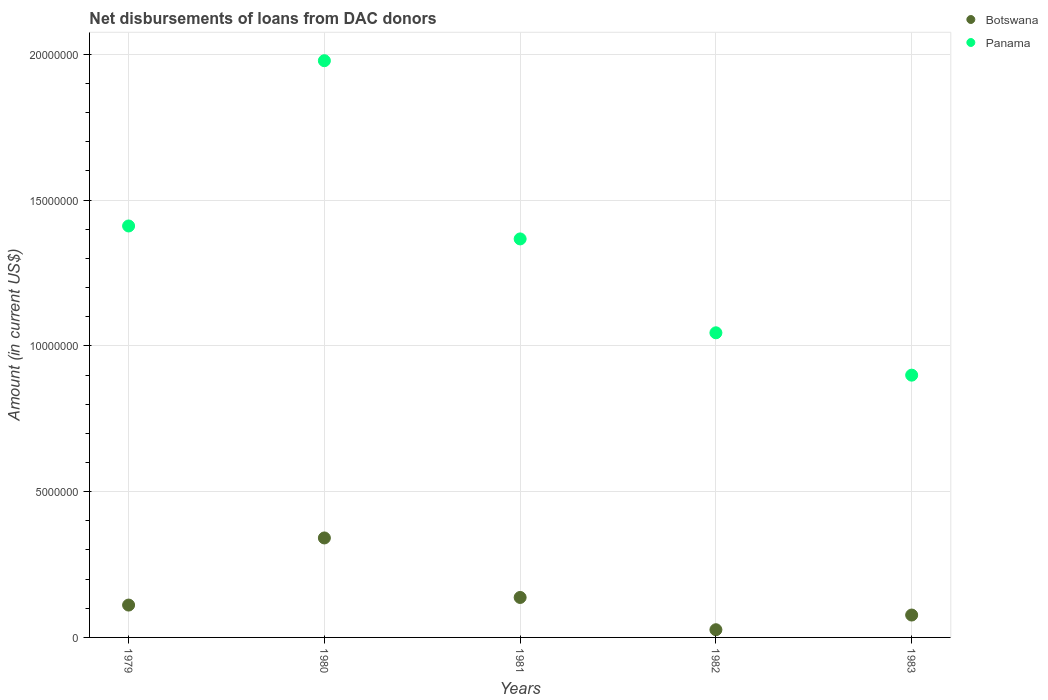What is the amount of loans disbursed in Panama in 1981?
Offer a terse response. 1.37e+07. Across all years, what is the maximum amount of loans disbursed in Botswana?
Make the answer very short. 3.41e+06. Across all years, what is the minimum amount of loans disbursed in Panama?
Make the answer very short. 9.00e+06. In which year was the amount of loans disbursed in Panama minimum?
Provide a short and direct response. 1983. What is the total amount of loans disbursed in Botswana in the graph?
Offer a very short reply. 6.92e+06. What is the difference between the amount of loans disbursed in Panama in 1980 and that in 1983?
Your answer should be compact. 1.08e+07. What is the difference between the amount of loans disbursed in Botswana in 1979 and the amount of loans disbursed in Panama in 1983?
Give a very brief answer. -7.89e+06. What is the average amount of loans disbursed in Panama per year?
Offer a very short reply. 1.34e+07. In the year 1983, what is the difference between the amount of loans disbursed in Botswana and amount of loans disbursed in Panama?
Offer a very short reply. -8.23e+06. What is the ratio of the amount of loans disbursed in Panama in 1979 to that in 1980?
Offer a terse response. 0.71. What is the difference between the highest and the second highest amount of loans disbursed in Botswana?
Keep it short and to the point. 2.04e+06. What is the difference between the highest and the lowest amount of loans disbursed in Panama?
Your answer should be compact. 1.08e+07. In how many years, is the amount of loans disbursed in Panama greater than the average amount of loans disbursed in Panama taken over all years?
Give a very brief answer. 3. Does the amount of loans disbursed in Panama monotonically increase over the years?
Keep it short and to the point. No. Is the amount of loans disbursed in Botswana strictly less than the amount of loans disbursed in Panama over the years?
Ensure brevity in your answer.  Yes. Does the graph contain any zero values?
Ensure brevity in your answer.  No. Where does the legend appear in the graph?
Keep it short and to the point. Top right. How are the legend labels stacked?
Keep it short and to the point. Vertical. What is the title of the graph?
Keep it short and to the point. Net disbursements of loans from DAC donors. What is the label or title of the Y-axis?
Offer a terse response. Amount (in current US$). What is the Amount (in current US$) in Botswana in 1979?
Ensure brevity in your answer.  1.11e+06. What is the Amount (in current US$) of Panama in 1979?
Ensure brevity in your answer.  1.41e+07. What is the Amount (in current US$) in Botswana in 1980?
Your response must be concise. 3.41e+06. What is the Amount (in current US$) in Panama in 1980?
Your answer should be very brief. 1.98e+07. What is the Amount (in current US$) in Botswana in 1981?
Give a very brief answer. 1.37e+06. What is the Amount (in current US$) of Panama in 1981?
Keep it short and to the point. 1.37e+07. What is the Amount (in current US$) in Botswana in 1982?
Provide a short and direct response. 2.64e+05. What is the Amount (in current US$) of Panama in 1982?
Offer a terse response. 1.04e+07. What is the Amount (in current US$) of Botswana in 1983?
Make the answer very short. 7.68e+05. What is the Amount (in current US$) in Panama in 1983?
Make the answer very short. 9.00e+06. Across all years, what is the maximum Amount (in current US$) of Botswana?
Offer a very short reply. 3.41e+06. Across all years, what is the maximum Amount (in current US$) of Panama?
Offer a terse response. 1.98e+07. Across all years, what is the minimum Amount (in current US$) in Botswana?
Make the answer very short. 2.64e+05. Across all years, what is the minimum Amount (in current US$) of Panama?
Keep it short and to the point. 9.00e+06. What is the total Amount (in current US$) in Botswana in the graph?
Your answer should be compact. 6.92e+06. What is the total Amount (in current US$) of Panama in the graph?
Provide a succinct answer. 6.70e+07. What is the difference between the Amount (in current US$) in Botswana in 1979 and that in 1980?
Offer a terse response. -2.30e+06. What is the difference between the Amount (in current US$) in Panama in 1979 and that in 1980?
Your answer should be compact. -5.67e+06. What is the difference between the Amount (in current US$) of Botswana in 1979 and that in 1981?
Ensure brevity in your answer.  -2.61e+05. What is the difference between the Amount (in current US$) in Panama in 1979 and that in 1981?
Offer a very short reply. 4.44e+05. What is the difference between the Amount (in current US$) in Botswana in 1979 and that in 1982?
Your answer should be compact. 8.46e+05. What is the difference between the Amount (in current US$) of Panama in 1979 and that in 1982?
Your answer should be compact. 3.66e+06. What is the difference between the Amount (in current US$) in Botswana in 1979 and that in 1983?
Keep it short and to the point. 3.42e+05. What is the difference between the Amount (in current US$) of Panama in 1979 and that in 1983?
Your response must be concise. 5.12e+06. What is the difference between the Amount (in current US$) of Botswana in 1980 and that in 1981?
Ensure brevity in your answer.  2.04e+06. What is the difference between the Amount (in current US$) of Panama in 1980 and that in 1981?
Your answer should be very brief. 6.11e+06. What is the difference between the Amount (in current US$) of Botswana in 1980 and that in 1982?
Your response must be concise. 3.15e+06. What is the difference between the Amount (in current US$) of Panama in 1980 and that in 1982?
Offer a terse response. 9.33e+06. What is the difference between the Amount (in current US$) in Botswana in 1980 and that in 1983?
Give a very brief answer. 2.64e+06. What is the difference between the Amount (in current US$) of Panama in 1980 and that in 1983?
Make the answer very short. 1.08e+07. What is the difference between the Amount (in current US$) in Botswana in 1981 and that in 1982?
Give a very brief answer. 1.11e+06. What is the difference between the Amount (in current US$) of Panama in 1981 and that in 1982?
Provide a short and direct response. 3.22e+06. What is the difference between the Amount (in current US$) of Botswana in 1981 and that in 1983?
Offer a very short reply. 6.03e+05. What is the difference between the Amount (in current US$) in Panama in 1981 and that in 1983?
Ensure brevity in your answer.  4.67e+06. What is the difference between the Amount (in current US$) in Botswana in 1982 and that in 1983?
Offer a terse response. -5.04e+05. What is the difference between the Amount (in current US$) in Panama in 1982 and that in 1983?
Your answer should be compact. 1.45e+06. What is the difference between the Amount (in current US$) in Botswana in 1979 and the Amount (in current US$) in Panama in 1980?
Ensure brevity in your answer.  -1.87e+07. What is the difference between the Amount (in current US$) of Botswana in 1979 and the Amount (in current US$) of Panama in 1981?
Provide a short and direct response. -1.26e+07. What is the difference between the Amount (in current US$) of Botswana in 1979 and the Amount (in current US$) of Panama in 1982?
Keep it short and to the point. -9.34e+06. What is the difference between the Amount (in current US$) in Botswana in 1979 and the Amount (in current US$) in Panama in 1983?
Provide a short and direct response. -7.89e+06. What is the difference between the Amount (in current US$) in Botswana in 1980 and the Amount (in current US$) in Panama in 1981?
Your answer should be compact. -1.03e+07. What is the difference between the Amount (in current US$) in Botswana in 1980 and the Amount (in current US$) in Panama in 1982?
Keep it short and to the point. -7.04e+06. What is the difference between the Amount (in current US$) of Botswana in 1980 and the Amount (in current US$) of Panama in 1983?
Your response must be concise. -5.58e+06. What is the difference between the Amount (in current US$) of Botswana in 1981 and the Amount (in current US$) of Panama in 1982?
Provide a succinct answer. -9.08e+06. What is the difference between the Amount (in current US$) in Botswana in 1981 and the Amount (in current US$) in Panama in 1983?
Make the answer very short. -7.62e+06. What is the difference between the Amount (in current US$) in Botswana in 1982 and the Amount (in current US$) in Panama in 1983?
Provide a succinct answer. -8.73e+06. What is the average Amount (in current US$) in Botswana per year?
Your answer should be very brief. 1.38e+06. What is the average Amount (in current US$) in Panama per year?
Provide a short and direct response. 1.34e+07. In the year 1979, what is the difference between the Amount (in current US$) in Botswana and Amount (in current US$) in Panama?
Your answer should be very brief. -1.30e+07. In the year 1980, what is the difference between the Amount (in current US$) in Botswana and Amount (in current US$) in Panama?
Offer a terse response. -1.64e+07. In the year 1981, what is the difference between the Amount (in current US$) of Botswana and Amount (in current US$) of Panama?
Ensure brevity in your answer.  -1.23e+07. In the year 1982, what is the difference between the Amount (in current US$) in Botswana and Amount (in current US$) in Panama?
Offer a terse response. -1.02e+07. In the year 1983, what is the difference between the Amount (in current US$) in Botswana and Amount (in current US$) in Panama?
Provide a short and direct response. -8.23e+06. What is the ratio of the Amount (in current US$) of Botswana in 1979 to that in 1980?
Keep it short and to the point. 0.33. What is the ratio of the Amount (in current US$) of Panama in 1979 to that in 1980?
Your response must be concise. 0.71. What is the ratio of the Amount (in current US$) in Botswana in 1979 to that in 1981?
Ensure brevity in your answer.  0.81. What is the ratio of the Amount (in current US$) of Panama in 1979 to that in 1981?
Your answer should be very brief. 1.03. What is the ratio of the Amount (in current US$) in Botswana in 1979 to that in 1982?
Offer a terse response. 4.2. What is the ratio of the Amount (in current US$) in Panama in 1979 to that in 1982?
Offer a terse response. 1.35. What is the ratio of the Amount (in current US$) in Botswana in 1979 to that in 1983?
Ensure brevity in your answer.  1.45. What is the ratio of the Amount (in current US$) in Panama in 1979 to that in 1983?
Give a very brief answer. 1.57. What is the ratio of the Amount (in current US$) in Botswana in 1980 to that in 1981?
Offer a very short reply. 2.49. What is the ratio of the Amount (in current US$) in Panama in 1980 to that in 1981?
Give a very brief answer. 1.45. What is the ratio of the Amount (in current US$) in Botswana in 1980 to that in 1982?
Keep it short and to the point. 12.92. What is the ratio of the Amount (in current US$) of Panama in 1980 to that in 1982?
Your answer should be very brief. 1.89. What is the ratio of the Amount (in current US$) of Botswana in 1980 to that in 1983?
Make the answer very short. 4.44. What is the ratio of the Amount (in current US$) of Panama in 1980 to that in 1983?
Make the answer very short. 2.2. What is the ratio of the Amount (in current US$) of Botswana in 1981 to that in 1982?
Keep it short and to the point. 5.19. What is the ratio of the Amount (in current US$) of Panama in 1981 to that in 1982?
Provide a succinct answer. 1.31. What is the ratio of the Amount (in current US$) of Botswana in 1981 to that in 1983?
Your answer should be very brief. 1.79. What is the ratio of the Amount (in current US$) in Panama in 1981 to that in 1983?
Your response must be concise. 1.52. What is the ratio of the Amount (in current US$) in Botswana in 1982 to that in 1983?
Your response must be concise. 0.34. What is the ratio of the Amount (in current US$) in Panama in 1982 to that in 1983?
Make the answer very short. 1.16. What is the difference between the highest and the second highest Amount (in current US$) of Botswana?
Your response must be concise. 2.04e+06. What is the difference between the highest and the second highest Amount (in current US$) of Panama?
Make the answer very short. 5.67e+06. What is the difference between the highest and the lowest Amount (in current US$) of Botswana?
Give a very brief answer. 3.15e+06. What is the difference between the highest and the lowest Amount (in current US$) of Panama?
Provide a short and direct response. 1.08e+07. 